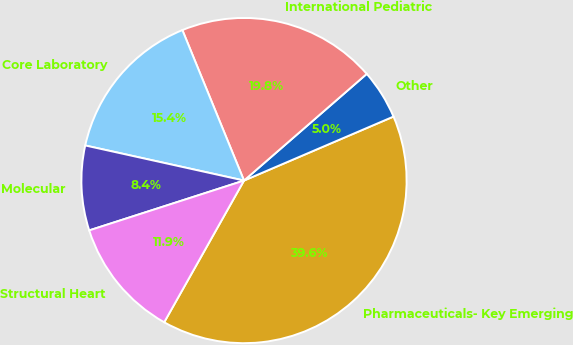<chart> <loc_0><loc_0><loc_500><loc_500><pie_chart><fcel>Pharmaceuticals- Key Emerging<fcel>Other<fcel>International Pediatric<fcel>Core Laboratory<fcel>Molecular<fcel>Structural Heart<nl><fcel>39.6%<fcel>4.95%<fcel>19.8%<fcel>15.35%<fcel>8.42%<fcel>11.88%<nl></chart> 